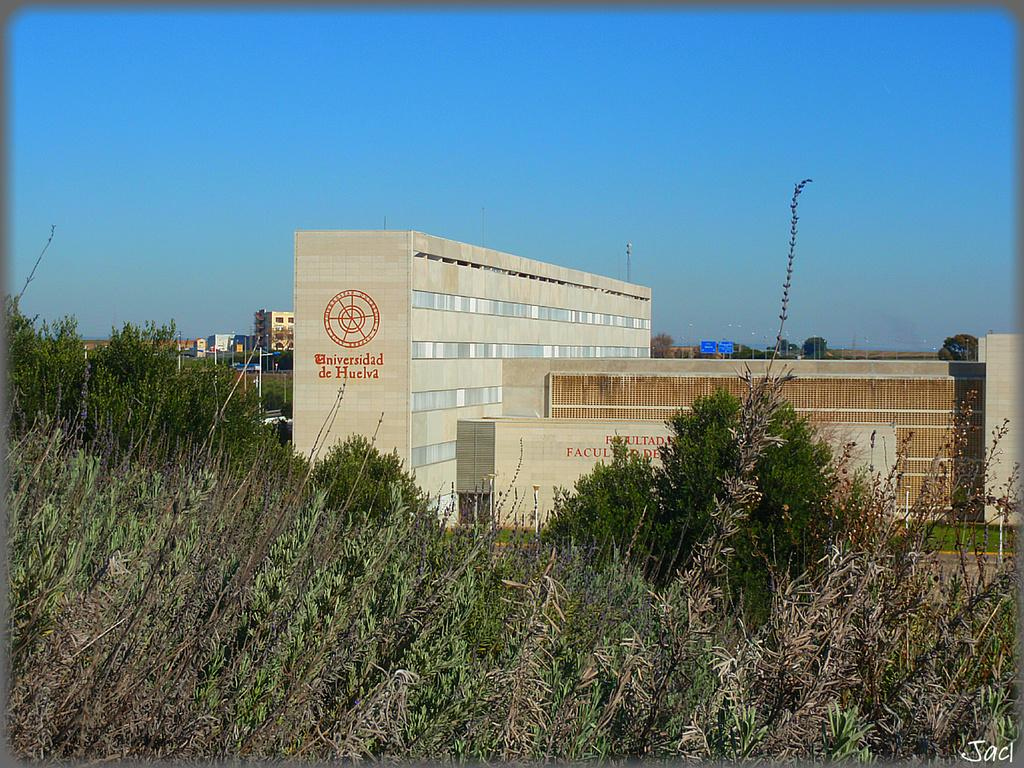What type of structure is present in the image? There is a building in the image. Can you describe the color of the building? The building is cream-colored. What other natural elements can be seen in the image? There are trees in the image. What is the color of the trees? The trees are green. What can be seen in the background of the image? There are other buildings visible in the background. What is the color of the sky in the image? The sky is blue. What type of chess piece is located on top of the building in the image? There is no chess piece present on top of the building in the image. What type of suit is the building wearing in the image? Buildings do not wear suits; the question is not applicable to the image. 